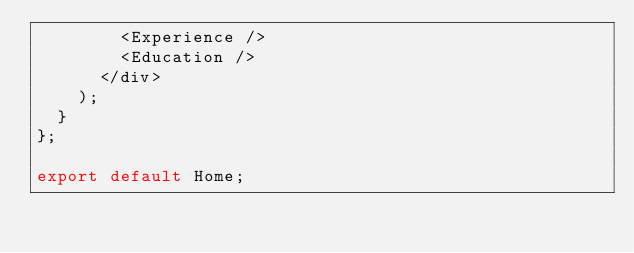<code> <loc_0><loc_0><loc_500><loc_500><_TypeScript_>        <Experience />
        <Education />
      </div>
    );
  }
};

export default Home;
</code> 